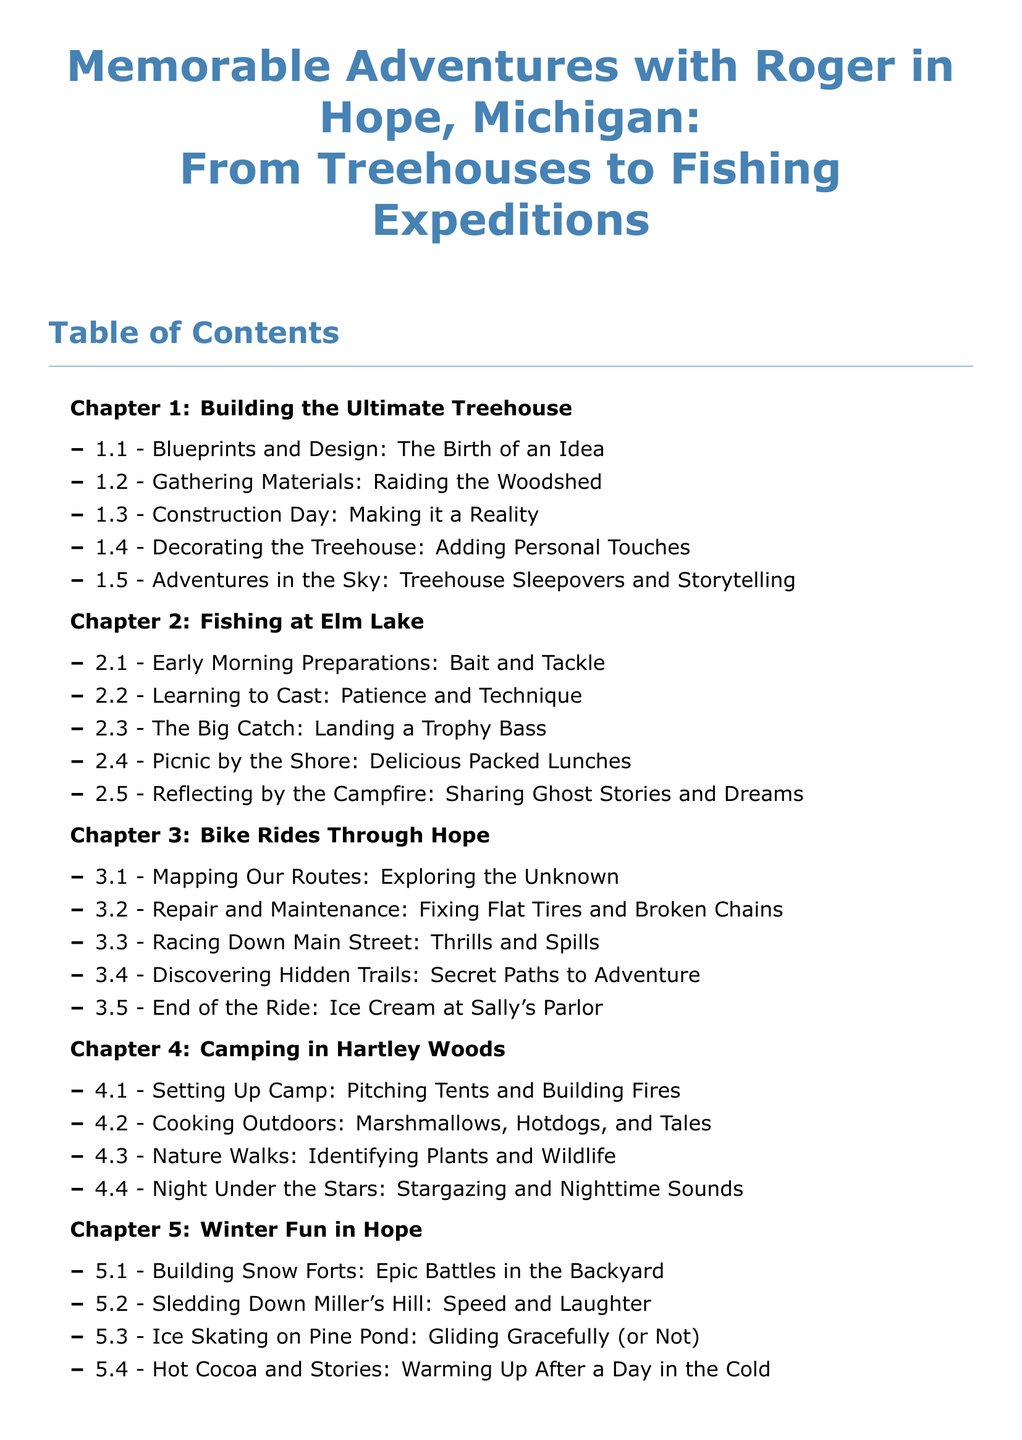What is the title of Chapter 1? The title of Chapter 1 is specified in the Table of Contents as "Building the Ultimate Treehouse."
Answer: Building the Ultimate Treehouse How many sections are in Chapter 2? Chapter 2 contains 5 sections listed in the Table of Contents.
Answer: 5 What is the last section of Chapter 3? The final section for Chapter 3 is listed in the Table of Contents as "End of the Ride: Ice Cream at Sally's Parlor."
Answer: End of the Ride: Ice Cream at Sally's Parlor What activity is highlighted in section 4.2? Section 4.2 focuses on cooking outdoors as part of Chapter 4.
Answer: Cooking Outdoors What is the first activity listed in Chapter 5? The first activity mentioned in Chapter 5 is "Building Snow Forts."
Answer: Building Snow Forts How many chapters are included in the document? The document includes a total of 5 chapters based on the Table of Contents.
Answer: 5 What theme is predominant in Chapter 4? The predominant theme of Chapter 4 revolves around camping activities in nature.
Answer: Camping 